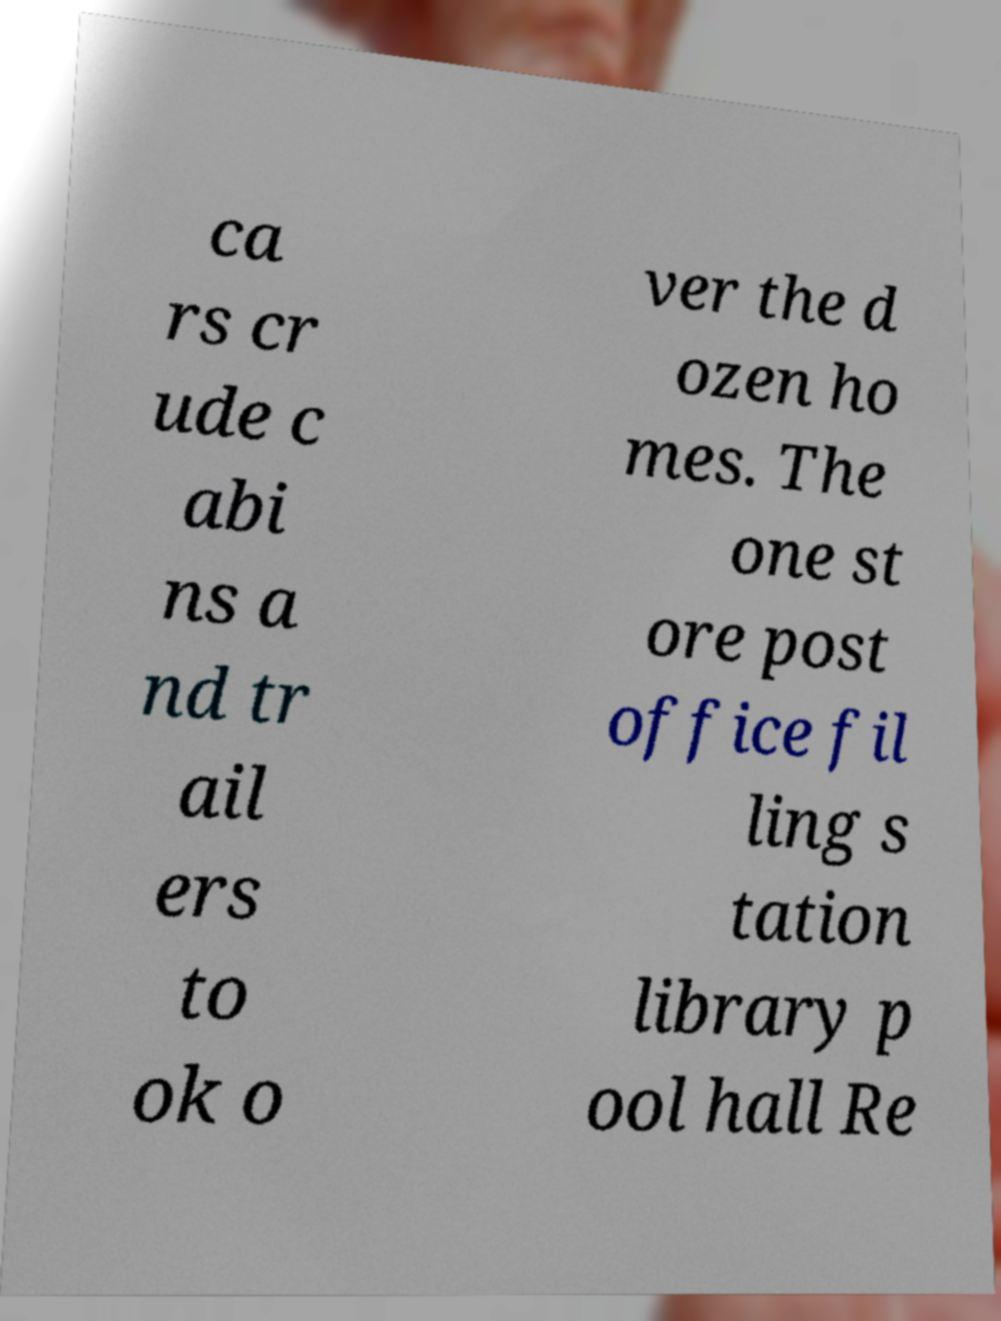Please identify and transcribe the text found in this image. ca rs cr ude c abi ns a nd tr ail ers to ok o ver the d ozen ho mes. The one st ore post office fil ling s tation library p ool hall Re 